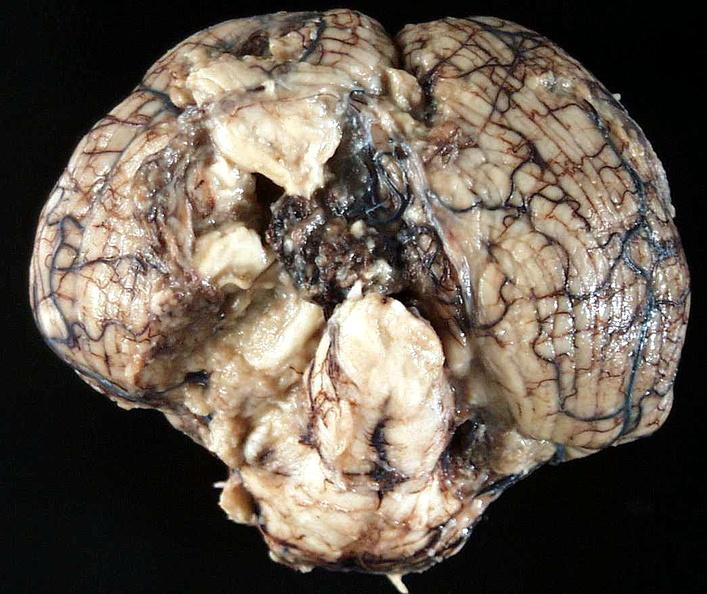does digital infarcts bacterial endocarditis show brain, cryptococcal meningitis?
Answer the question using a single word or phrase. No 